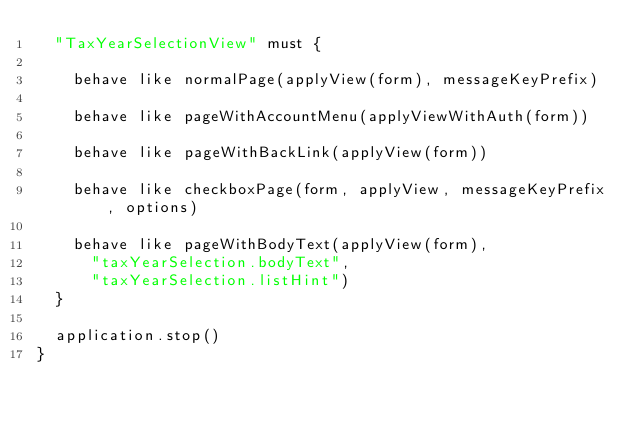Convert code to text. <code><loc_0><loc_0><loc_500><loc_500><_Scala_>  "TaxYearSelectionView" must {

    behave like normalPage(applyView(form), messageKeyPrefix)

    behave like pageWithAccountMenu(applyViewWithAuth(form))

    behave like pageWithBackLink(applyView(form))

    behave like checkboxPage(form, applyView, messageKeyPrefix, options)

    behave like pageWithBodyText(applyView(form),
      "taxYearSelection.bodyText",
      "taxYearSelection.listHint")
  }

  application.stop()
}
</code> 